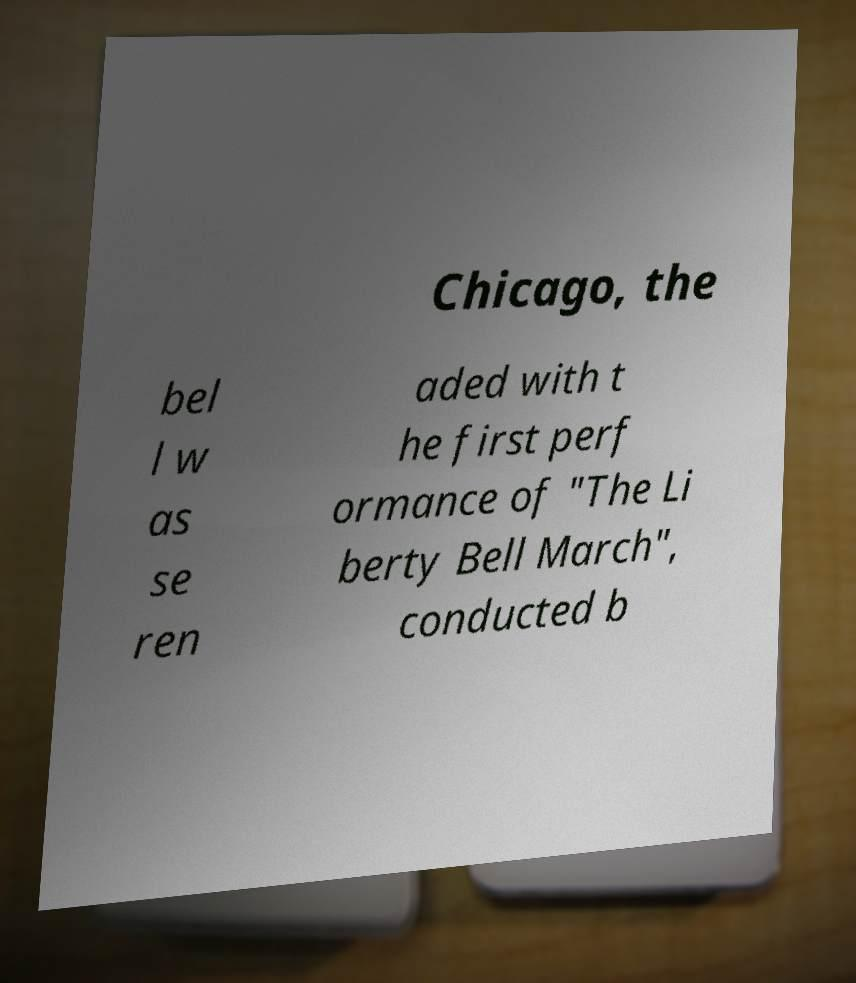Could you extract and type out the text from this image? Chicago, the bel l w as se ren aded with t he first perf ormance of "The Li berty Bell March", conducted b 